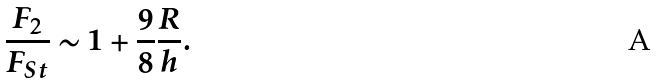<formula> <loc_0><loc_0><loc_500><loc_500>\frac { F _ { 2 } } { F _ { S t } } \sim 1 + \frac { 9 } { 8 } \frac { R } { h } .</formula> 